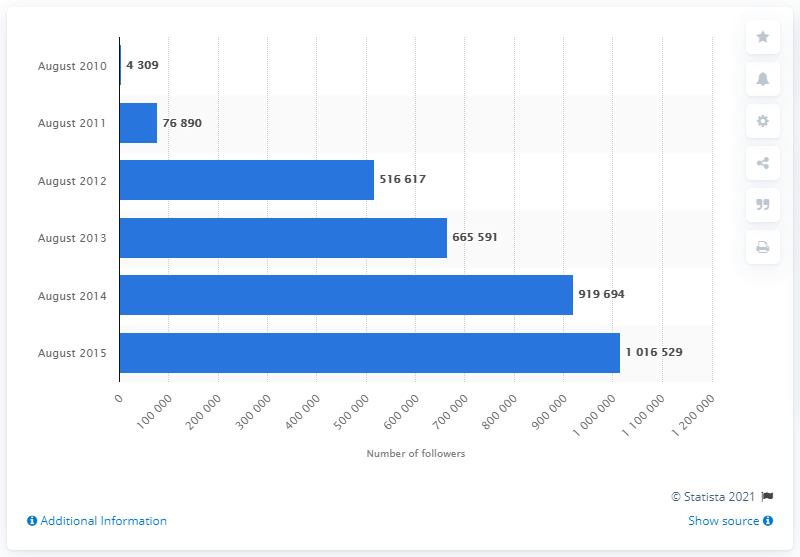Highlight a few significant elements in this photo. In August 2015, Argos had 4,309 followers. In August 2010, Argos had 4,309 followers on Facebook. 